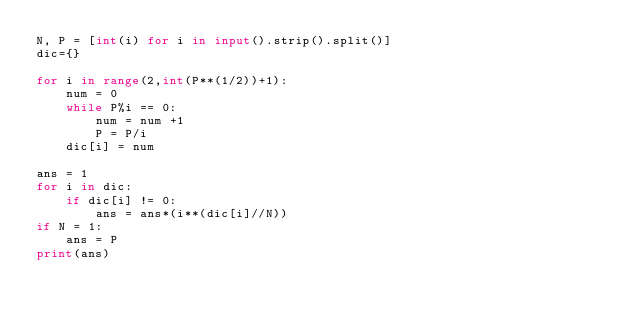Convert code to text. <code><loc_0><loc_0><loc_500><loc_500><_Python_>N, P = [int(i) for i in input().strip().split()]
dic={}

for i in range(2,int(P**(1/2))+1):
    num = 0
    while P%i == 0:
        num = num +1
        P = P/i
    dic[i] = num
    
ans = 1
for i in dic:
    if dic[i] != 0:
        ans = ans*(i**(dic[i]//N))
if N = 1:
    ans = P
print(ans)</code> 